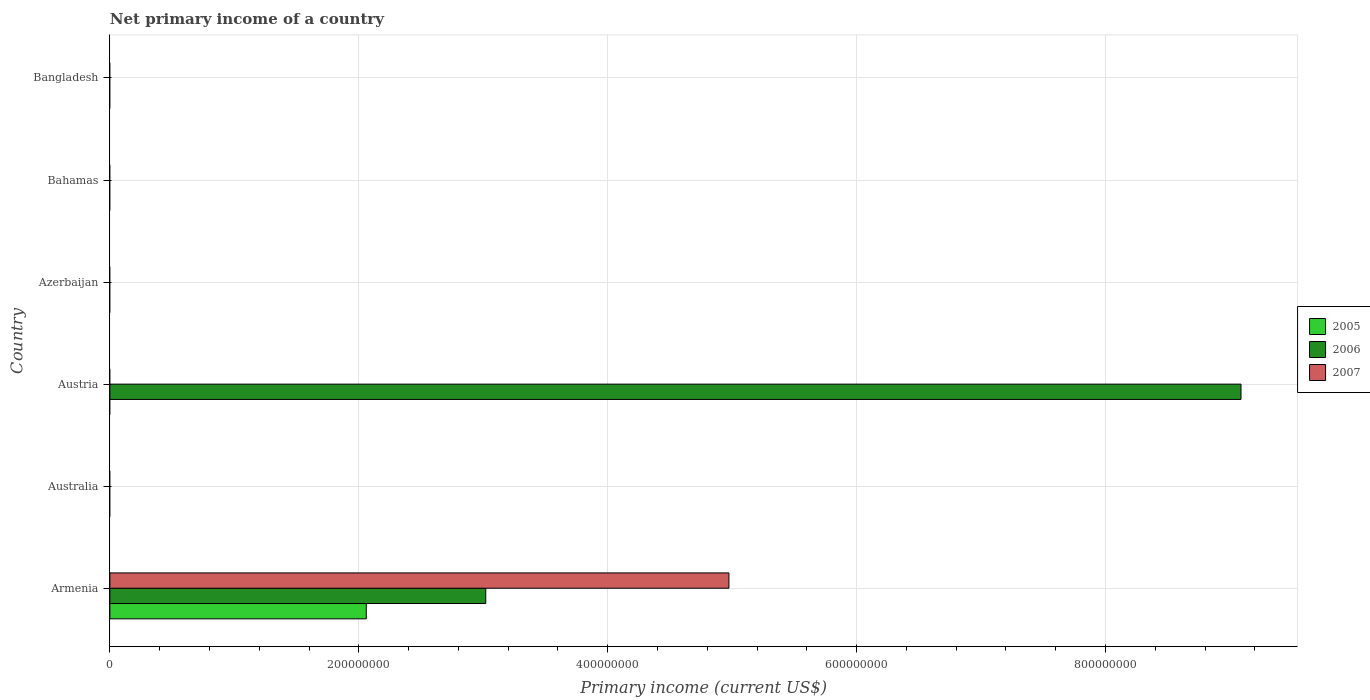How many different coloured bars are there?
Offer a very short reply. 3. Are the number of bars per tick equal to the number of legend labels?
Make the answer very short. No. In how many cases, is the number of bars for a given country not equal to the number of legend labels?
Ensure brevity in your answer.  5. Across all countries, what is the maximum primary income in 2006?
Your response must be concise. 9.09e+08. Across all countries, what is the minimum primary income in 2007?
Ensure brevity in your answer.  0. What is the total primary income in 2007 in the graph?
Provide a short and direct response. 4.97e+08. What is the difference between the primary income in 2005 in Bahamas and the primary income in 2006 in Austria?
Offer a very short reply. -9.09e+08. What is the average primary income in 2007 per country?
Provide a short and direct response. 8.29e+07. What is the difference between the highest and the lowest primary income in 2005?
Give a very brief answer. 2.06e+08. Is the sum of the primary income in 2006 in Armenia and Austria greater than the maximum primary income in 2007 across all countries?
Offer a very short reply. Yes. Is it the case that in every country, the sum of the primary income in 2005 and primary income in 2006 is greater than the primary income in 2007?
Keep it short and to the point. No. Are all the bars in the graph horizontal?
Keep it short and to the point. Yes. How many countries are there in the graph?
Ensure brevity in your answer.  6. What is the difference between two consecutive major ticks on the X-axis?
Provide a short and direct response. 2.00e+08. Are the values on the major ticks of X-axis written in scientific E-notation?
Your answer should be very brief. No. Does the graph contain grids?
Your response must be concise. Yes. How many legend labels are there?
Make the answer very short. 3. What is the title of the graph?
Keep it short and to the point. Net primary income of a country. What is the label or title of the X-axis?
Your answer should be very brief. Primary income (current US$). What is the Primary income (current US$) in 2005 in Armenia?
Offer a very short reply. 2.06e+08. What is the Primary income (current US$) in 2006 in Armenia?
Your response must be concise. 3.02e+08. What is the Primary income (current US$) in 2007 in Armenia?
Provide a succinct answer. 4.97e+08. What is the Primary income (current US$) of 2005 in Australia?
Provide a succinct answer. 0. What is the Primary income (current US$) in 2007 in Australia?
Provide a succinct answer. 0. What is the Primary income (current US$) of 2006 in Austria?
Your response must be concise. 9.09e+08. What is the Primary income (current US$) in 2006 in Bahamas?
Provide a succinct answer. 0. What is the Primary income (current US$) of 2007 in Bahamas?
Your response must be concise. 0. What is the Primary income (current US$) in 2005 in Bangladesh?
Keep it short and to the point. 0. Across all countries, what is the maximum Primary income (current US$) in 2005?
Your answer should be very brief. 2.06e+08. Across all countries, what is the maximum Primary income (current US$) of 2006?
Provide a short and direct response. 9.09e+08. Across all countries, what is the maximum Primary income (current US$) in 2007?
Your answer should be very brief. 4.97e+08. Across all countries, what is the minimum Primary income (current US$) of 2006?
Give a very brief answer. 0. What is the total Primary income (current US$) of 2005 in the graph?
Ensure brevity in your answer.  2.06e+08. What is the total Primary income (current US$) in 2006 in the graph?
Keep it short and to the point. 1.21e+09. What is the total Primary income (current US$) of 2007 in the graph?
Your answer should be compact. 4.97e+08. What is the difference between the Primary income (current US$) in 2006 in Armenia and that in Austria?
Your answer should be compact. -6.07e+08. What is the difference between the Primary income (current US$) in 2005 in Armenia and the Primary income (current US$) in 2006 in Austria?
Keep it short and to the point. -7.03e+08. What is the average Primary income (current US$) of 2005 per country?
Your answer should be very brief. 3.43e+07. What is the average Primary income (current US$) in 2006 per country?
Your answer should be compact. 2.02e+08. What is the average Primary income (current US$) of 2007 per country?
Give a very brief answer. 8.29e+07. What is the difference between the Primary income (current US$) in 2005 and Primary income (current US$) in 2006 in Armenia?
Keep it short and to the point. -9.60e+07. What is the difference between the Primary income (current US$) in 2005 and Primary income (current US$) in 2007 in Armenia?
Keep it short and to the point. -2.91e+08. What is the difference between the Primary income (current US$) of 2006 and Primary income (current US$) of 2007 in Armenia?
Keep it short and to the point. -1.95e+08. What is the ratio of the Primary income (current US$) in 2006 in Armenia to that in Austria?
Provide a short and direct response. 0.33. What is the difference between the highest and the lowest Primary income (current US$) of 2005?
Provide a short and direct response. 2.06e+08. What is the difference between the highest and the lowest Primary income (current US$) of 2006?
Your response must be concise. 9.09e+08. What is the difference between the highest and the lowest Primary income (current US$) in 2007?
Your answer should be compact. 4.97e+08. 